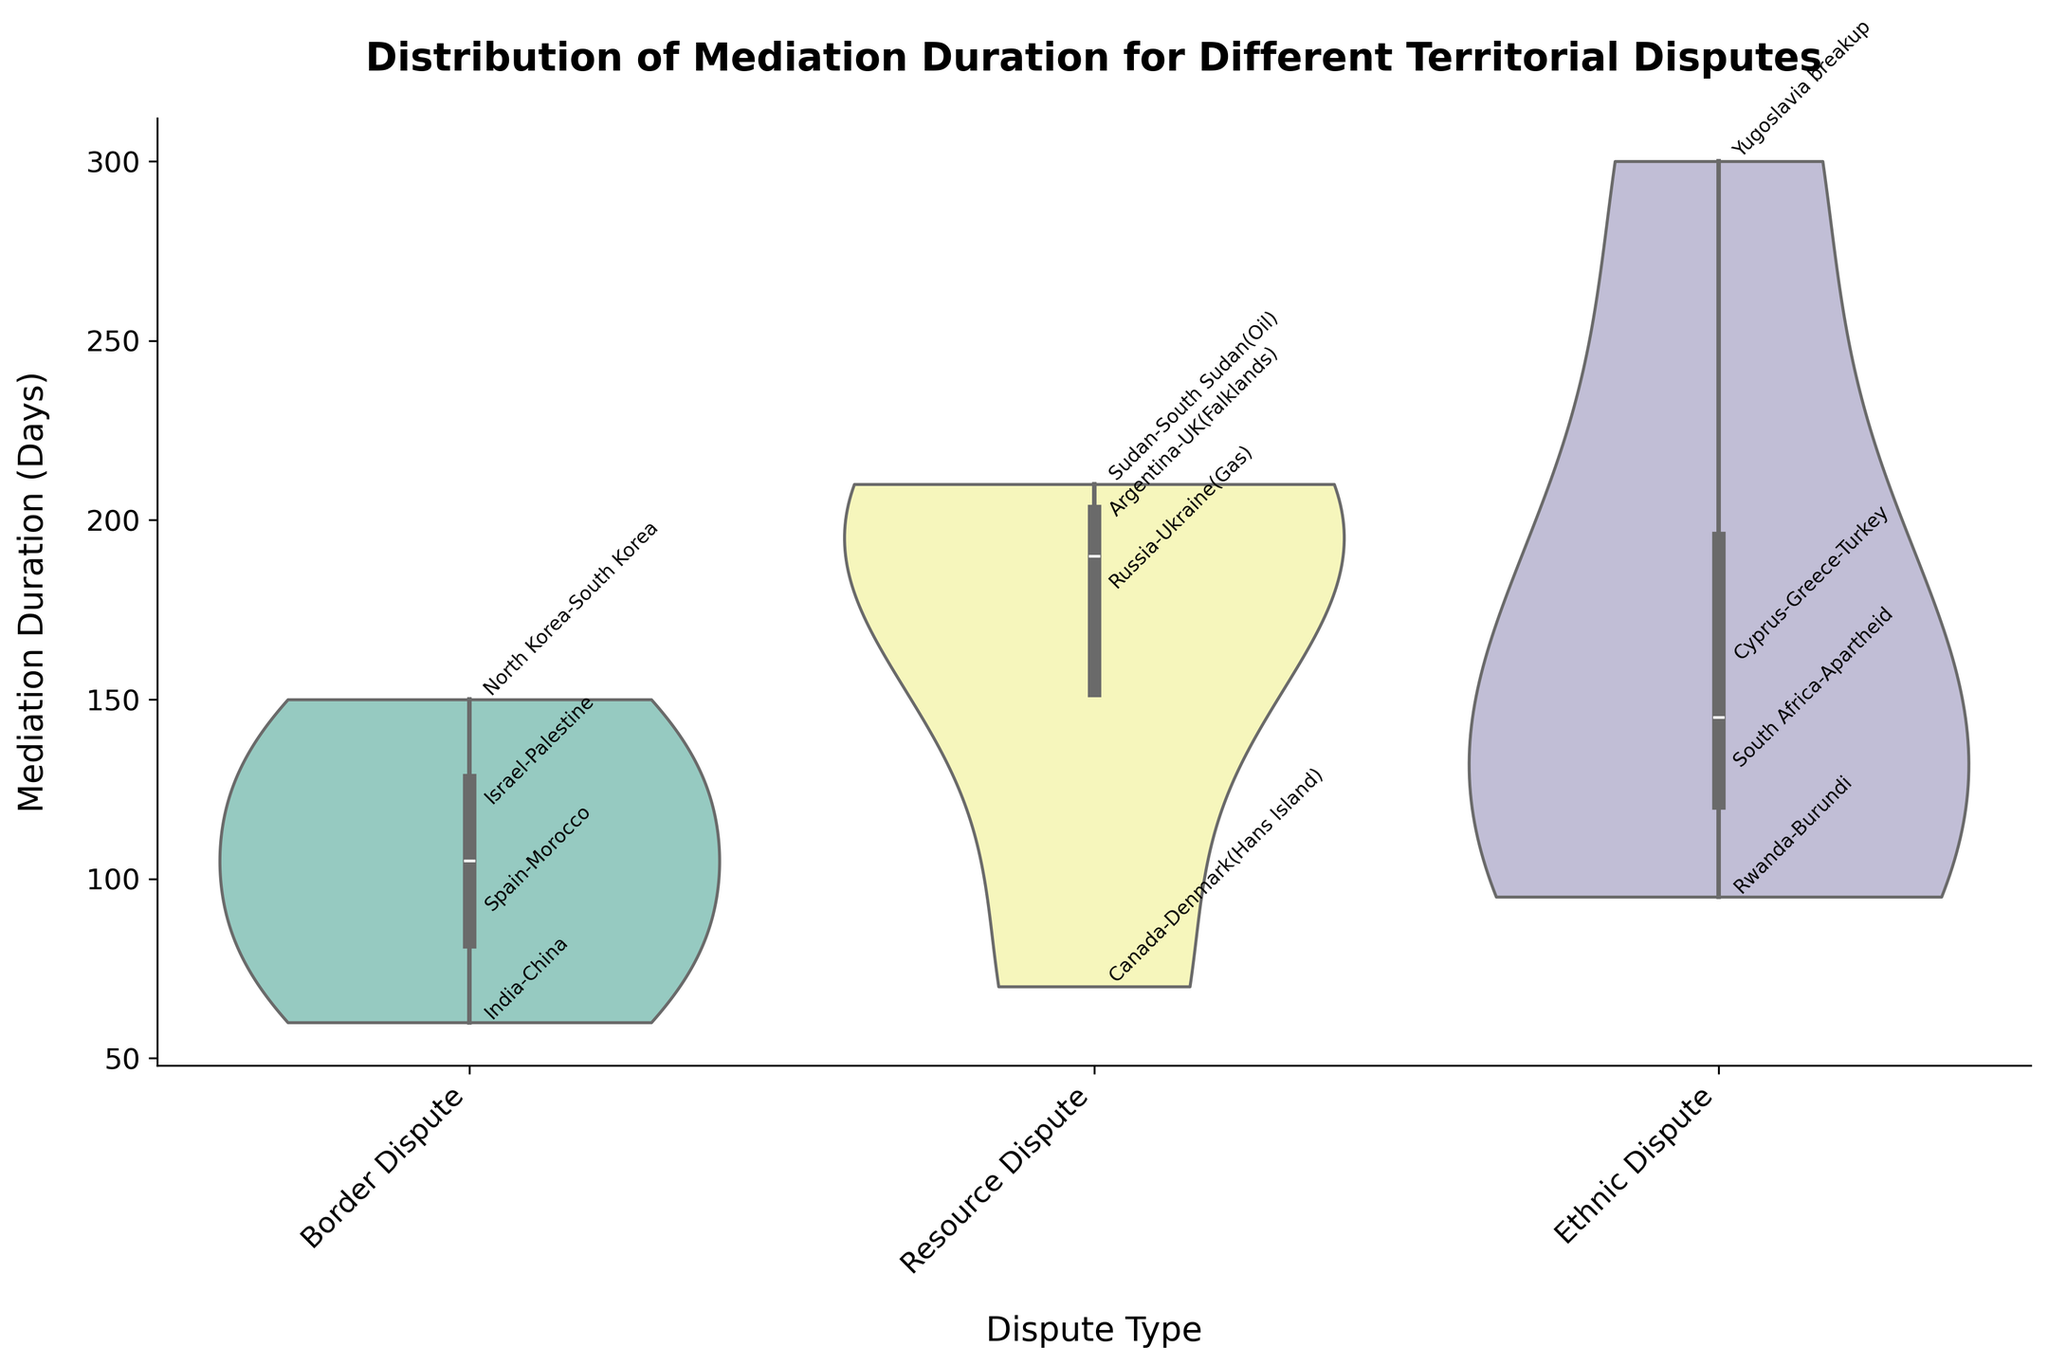What is the title of the plot? The title is located at the top of the plot. It summarizes what the plot represents. In this case, it reads: 'Distribution of Mediation Duration for Different Territorial Disputes'.
Answer: Distribution of Mediation Duration for Different Territorial Disputes How many types of territorial disputes are illustrated in the plot? By looking at the x-axis, we see three distinct categories which are: Border Dispute, Resource Dispute, and Ethnic Dispute.
Answer: 3 Which dispute type has the widest range of mediation duration times? By observing the overall spread of the violin plots, it is evident which plot spans the most on the y-axis. The Ethnic Dispute category shows the widest spread from 95 to 300 days.
Answer: Ethnic Dispute What is the median duration for Resource Dispute mediations? Median values are indicated by the central white dot inside the violin plot. For Resource Dispute, this value appears to be around 195 days.
Answer: 195 days Which territorial dispute type shows the least variation in mediation duration? The least variation is identified by the narrowest violin plot. The Border Dispute category appears to have the least spread.
Answer: Border Dispute How does the longest mediation duration for Border Disputes compare to the longest duration for Resource Disputes? We need to look at the top ends of both violin plots and compare the values. The longest for Border Disputes is 150 days, while for Resource Disputes it's 210 days. The Resource Dispute duration is thus longer.
Answer: Resource Dispute has longer duration What is the shortest duration for an Ethnic Dispute mediation? By checking the bottom end of the Ethnic Dispute's violin plot, we see that the shortest duration is 95 days, corresponding to the Rwanda-Burundi dispute.
Answer: 95 days Which specific dispute has the longest mediation duration among all the disputes in the plot? This requires identifying the highest point on any of the violin plots. The longest duration, 300 days, is seen in the Ethnic Dispute category, corresponding to the Yugoslavia breakup.
Answer: Yugoslavia breakup What is the approximate range of mediation durations for Resource Disputes? The total range is the difference between the highest and lowest points of the violin plot. For Resource Disputes, the range is from about 70 days to 210 days, giving an approximate range of 140 days.
Answer: 140 days 